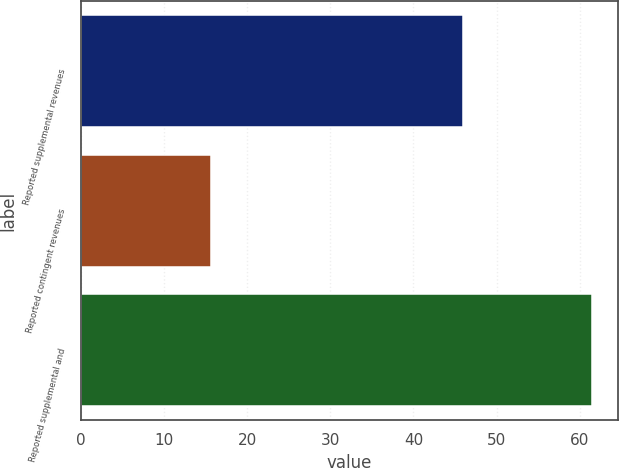<chart> <loc_0><loc_0><loc_500><loc_500><bar_chart><fcel>Reported supplemental revenues<fcel>Reported contingent revenues<fcel>Reported supplemental and<nl><fcel>45.9<fcel>15.6<fcel>61.5<nl></chart> 